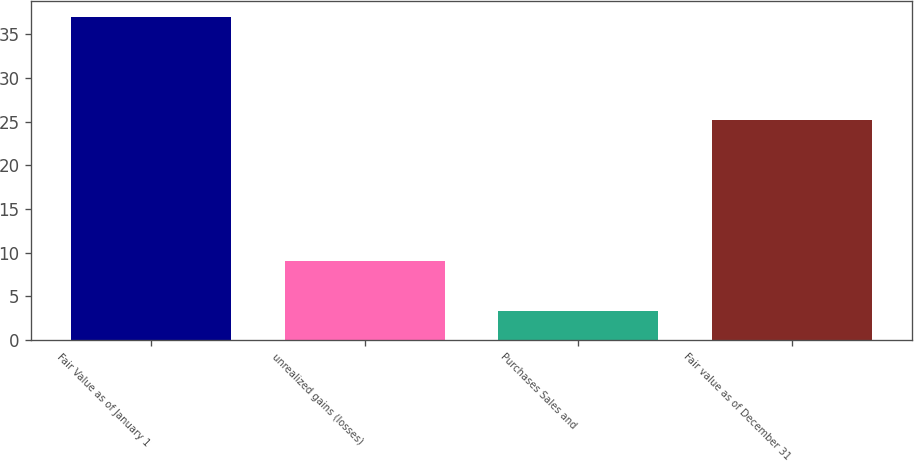Convert chart. <chart><loc_0><loc_0><loc_500><loc_500><bar_chart><fcel>Fair Value as of January 1<fcel>unrealized gains (losses)<fcel>Purchases Sales and<fcel>Fair value as of December 31<nl><fcel>36.9<fcel>9<fcel>3.3<fcel>25.2<nl></chart> 